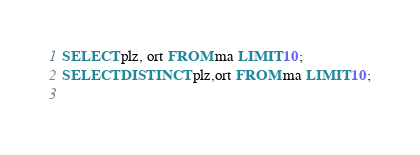<code> <loc_0><loc_0><loc_500><loc_500><_SQL_>SELECT plz, ort FROM ma LIMIT 10;
SELECT DISTINCT plz,ort FROM ma LIMIT 10;
 </code> 